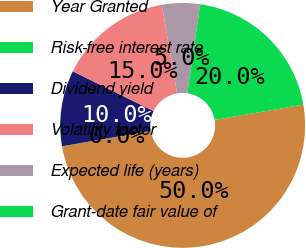<chart> <loc_0><loc_0><loc_500><loc_500><pie_chart><fcel>Year Granted<fcel>Risk-free interest rate<fcel>Dividend yield<fcel>Volatility factor<fcel>Expected life (years)<fcel>Grant-date fair value of<nl><fcel>49.96%<fcel>0.02%<fcel>10.01%<fcel>15.0%<fcel>5.01%<fcel>20.0%<nl></chart> 